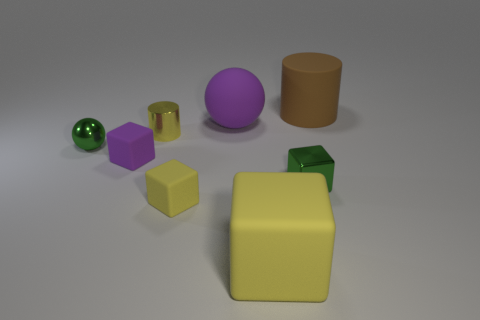Subtract all rubber blocks. How many blocks are left? 1 Add 2 big cylinders. How many objects exist? 10 Subtract all cyan cylinders. How many yellow cubes are left? 2 Subtract all yellow cubes. How many cubes are left? 2 Subtract all cyan blocks. Subtract all red cylinders. How many blocks are left? 4 Subtract all large brown matte cylinders. Subtract all large cylinders. How many objects are left? 6 Add 1 small metal cubes. How many small metal cubes are left? 2 Add 8 purple shiny cylinders. How many purple shiny cylinders exist? 8 Subtract 0 green cylinders. How many objects are left? 8 Subtract all balls. How many objects are left? 6 